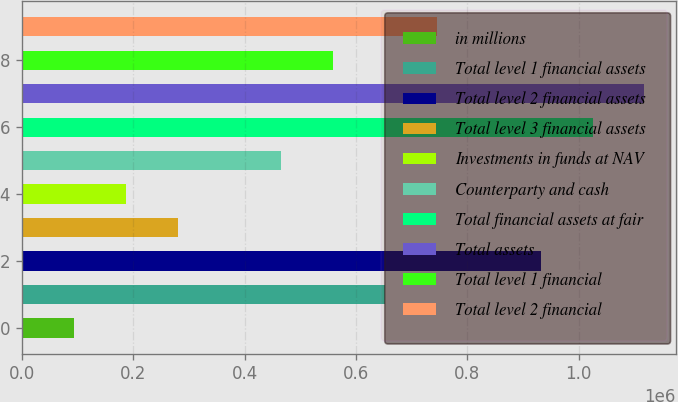<chart> <loc_0><loc_0><loc_500><loc_500><bar_chart><fcel>in millions<fcel>Total level 1 financial assets<fcel>Total level 2 financial assets<fcel>Total level 3 financial assets<fcel>Investments in funds at NAV<fcel>Counterparty and cash<fcel>Total financial assets at fair<fcel>Total assets<fcel>Total level 1 financial<fcel>Total level 2 financial<nl><fcel>93186.8<fcel>652260<fcel>931796<fcel>279544<fcel>186366<fcel>465902<fcel>1.02497e+06<fcel>1.11815e+06<fcel>559081<fcel>745438<nl></chart> 